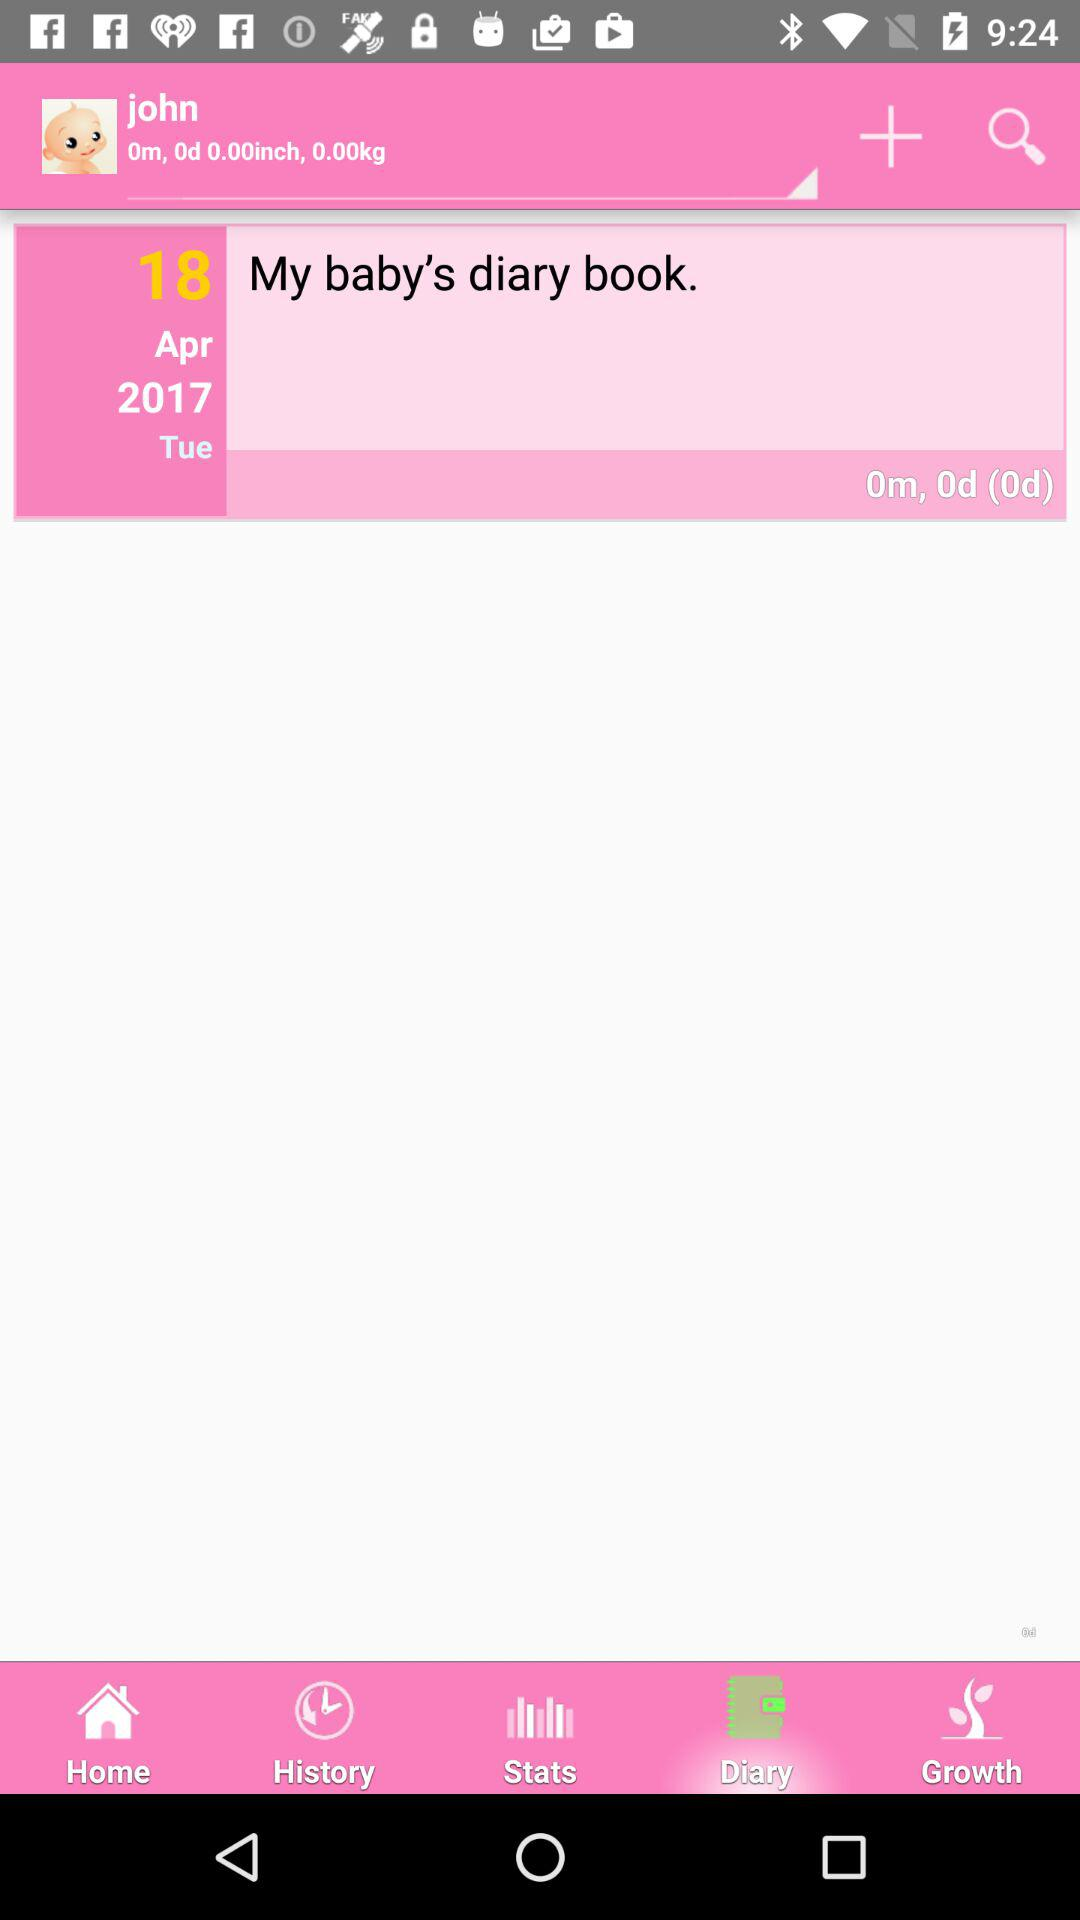What is the date shown on the screen? The date is Tuesday, April 18, 2017. 